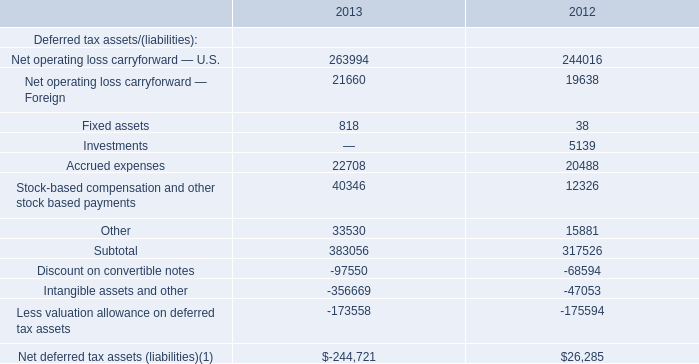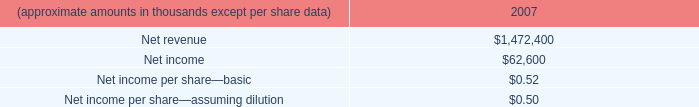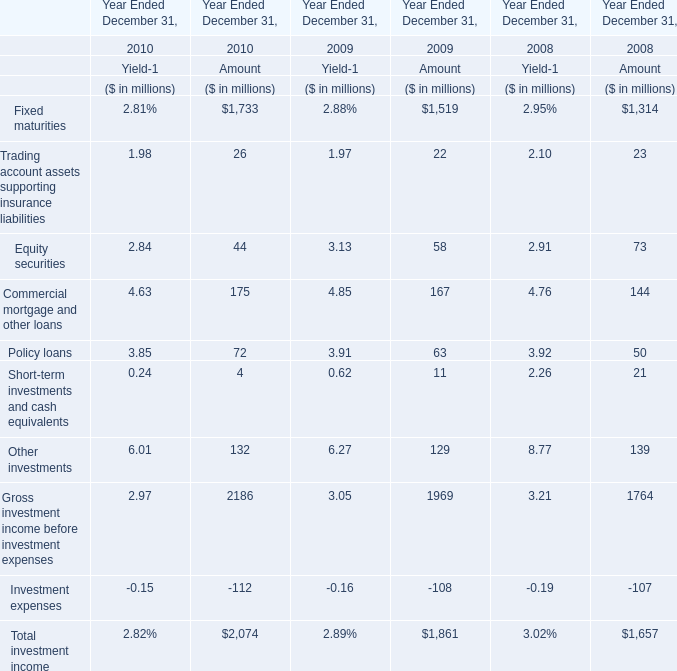What is the sum of Equity securities of Amount in 2009 and Fixed assets in 2012? (in million) 
Computations: (58 + 38)
Answer: 96.0. 